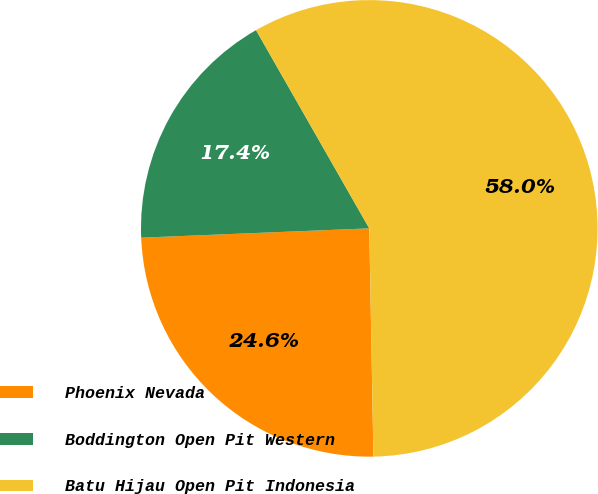Convert chart. <chart><loc_0><loc_0><loc_500><loc_500><pie_chart><fcel>Phoenix Nevada<fcel>Boddington Open Pit Western<fcel>Batu Hijau Open Pit Indonesia<nl><fcel>24.64%<fcel>17.39%<fcel>57.97%<nl></chart> 